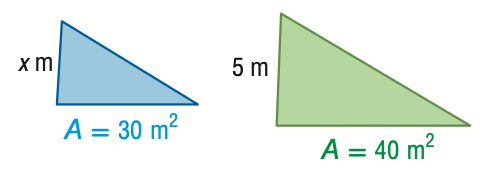Question: For the pair of similar figures, use the given areas to find x.
Choices:
A. 3.7
B. 4.3
C. 5.8
D. 6.7
Answer with the letter. Answer: B 